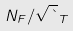<formula> <loc_0><loc_0><loc_500><loc_500>N _ { F } / \sqrt { \theta } _ { T }</formula> 